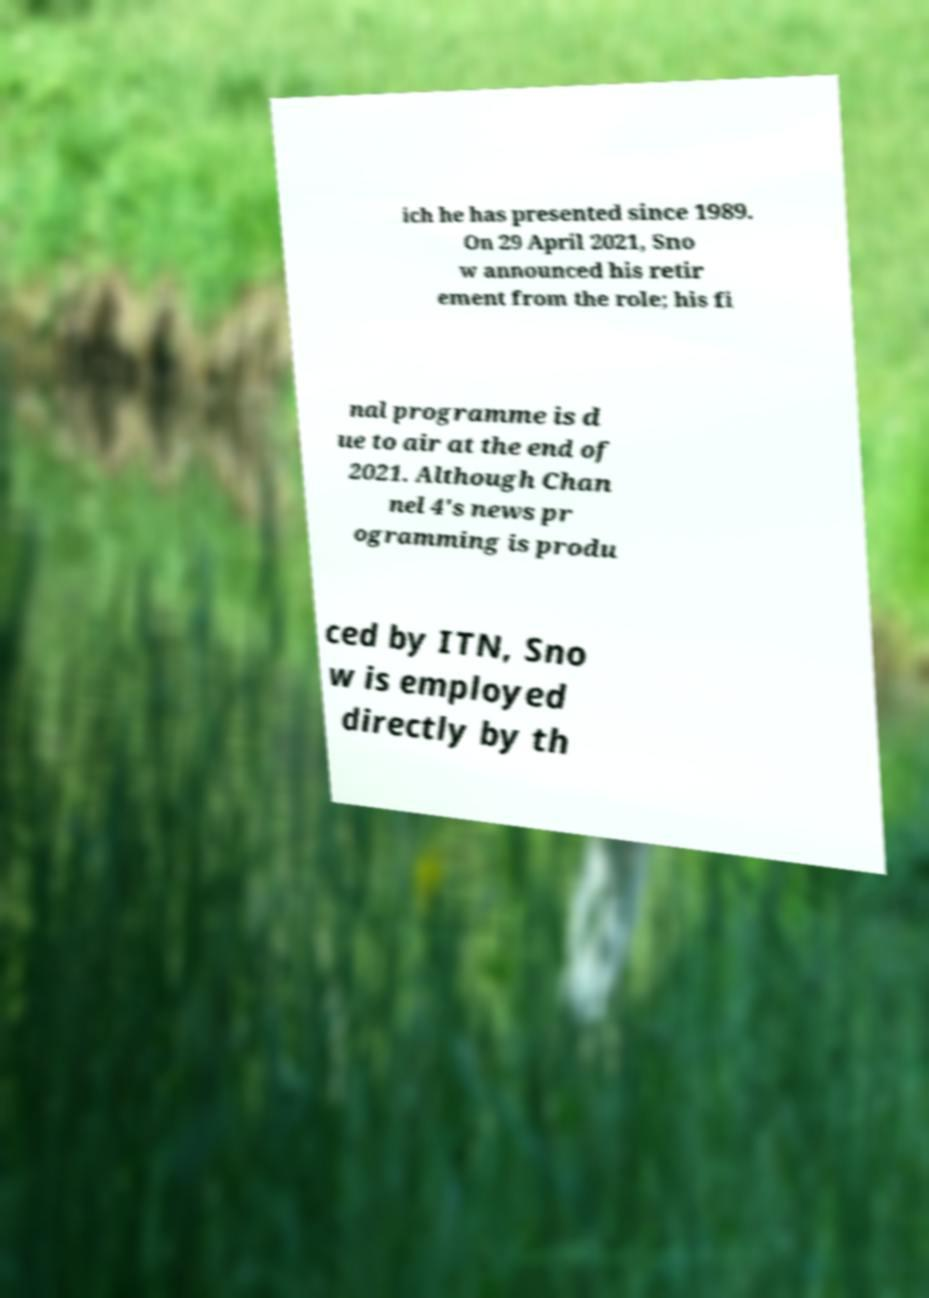Can you accurately transcribe the text from the provided image for me? ich he has presented since 1989. On 29 April 2021, Sno w announced his retir ement from the role; his fi nal programme is d ue to air at the end of 2021. Although Chan nel 4's news pr ogramming is produ ced by ITN, Sno w is employed directly by th 